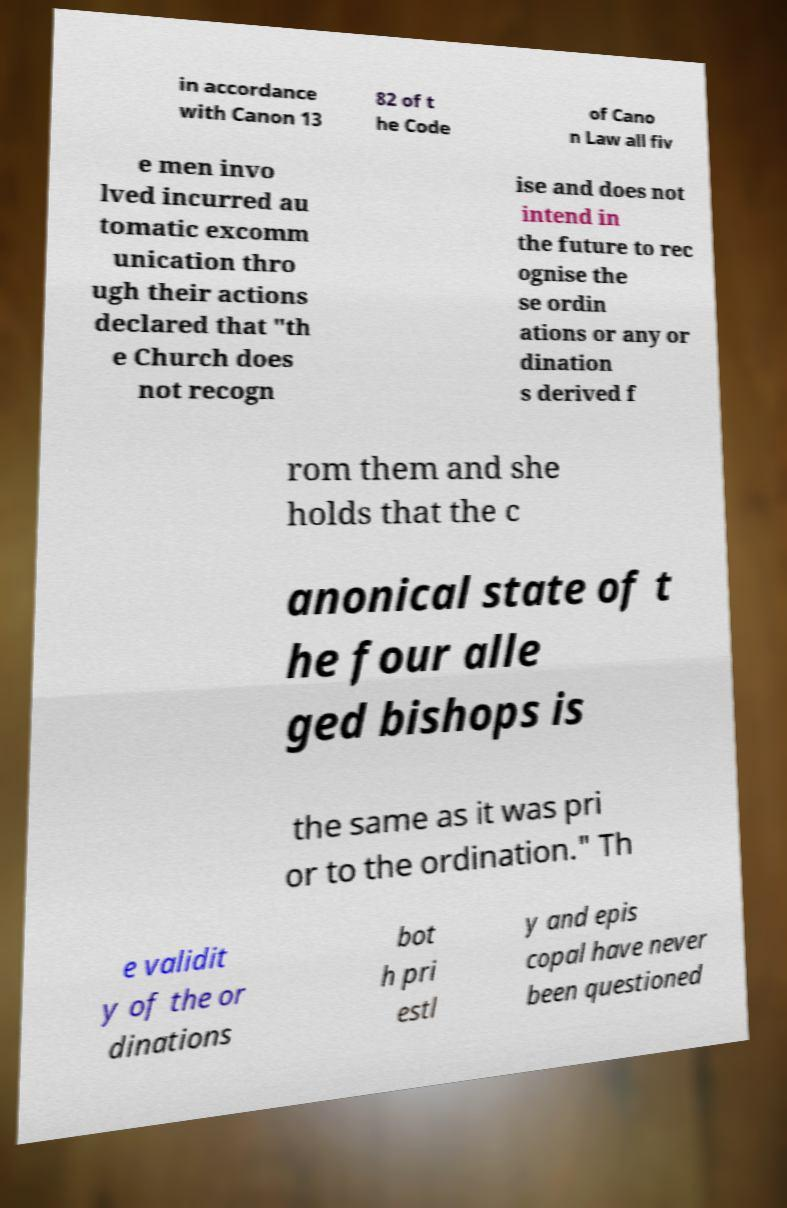For documentation purposes, I need the text within this image transcribed. Could you provide that? in accordance with Canon 13 82 of t he Code of Cano n Law all fiv e men invo lved incurred au tomatic excomm unication thro ugh their actions declared that "th e Church does not recogn ise and does not intend in the future to rec ognise the se ordin ations or any or dination s derived f rom them and she holds that the c anonical state of t he four alle ged bishops is the same as it was pri or to the ordination." Th e validit y of the or dinations bot h pri estl y and epis copal have never been questioned 